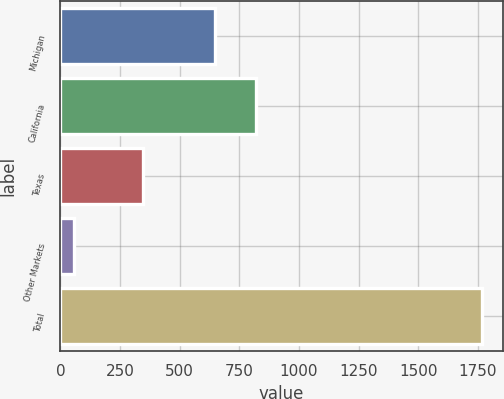Convert chart to OTSL. <chart><loc_0><loc_0><loc_500><loc_500><bar_chart><fcel>Michigan<fcel>California<fcel>Texas<fcel>Other Markets<fcel>Total<nl><fcel>650<fcel>820.6<fcel>346<fcel>59<fcel>1765<nl></chart> 